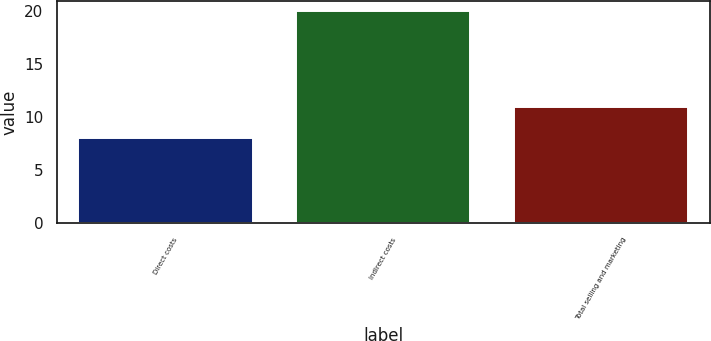Convert chart to OTSL. <chart><loc_0><loc_0><loc_500><loc_500><bar_chart><fcel>Direct costs<fcel>Indirect costs<fcel>Total selling and marketing<nl><fcel>8<fcel>20<fcel>11<nl></chart> 